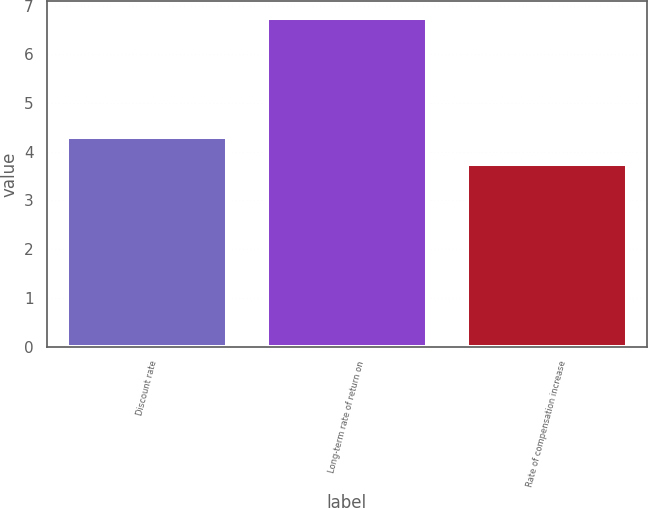Convert chart. <chart><loc_0><loc_0><loc_500><loc_500><bar_chart><fcel>Discount rate<fcel>Long-term rate of return on<fcel>Rate of compensation increase<nl><fcel>4.3<fcel>6.75<fcel>3.75<nl></chart> 